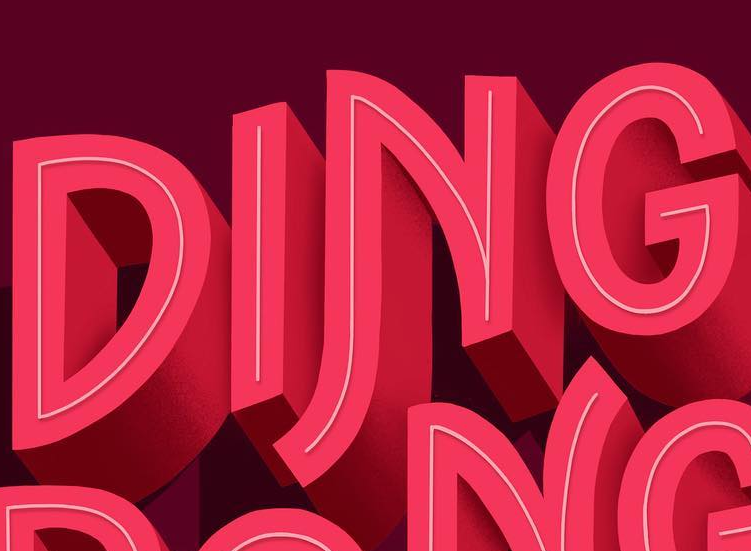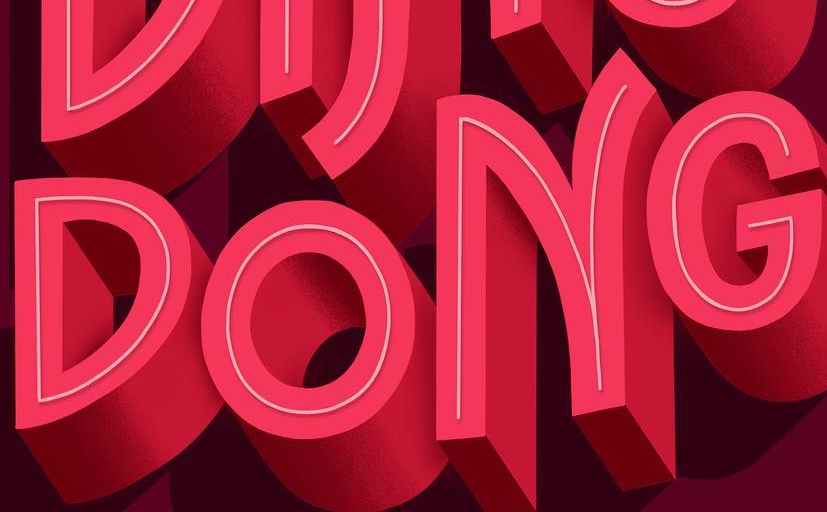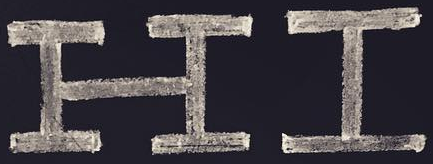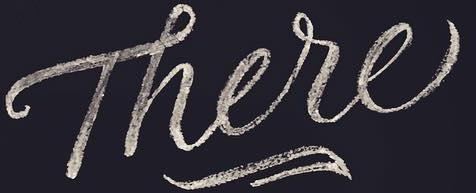What words can you see in these images in sequence, separated by a semicolon? DING; DONG; HI; There 